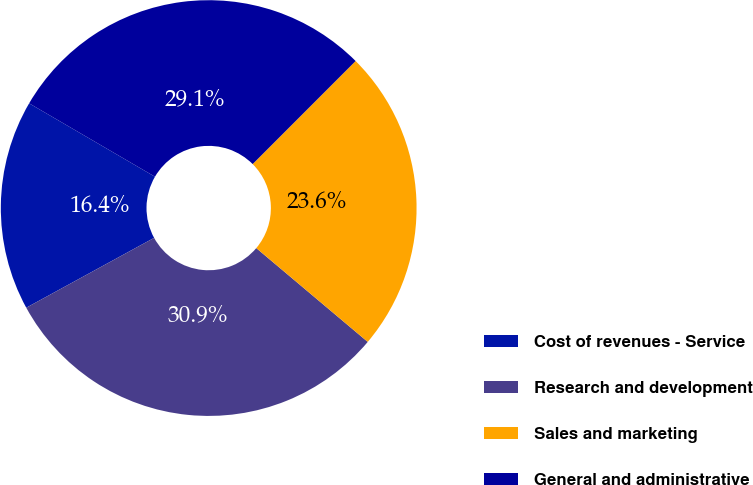<chart> <loc_0><loc_0><loc_500><loc_500><pie_chart><fcel>Cost of revenues - Service<fcel>Research and development<fcel>Sales and marketing<fcel>General and administrative<nl><fcel>16.36%<fcel>30.91%<fcel>23.64%<fcel>29.09%<nl></chart> 